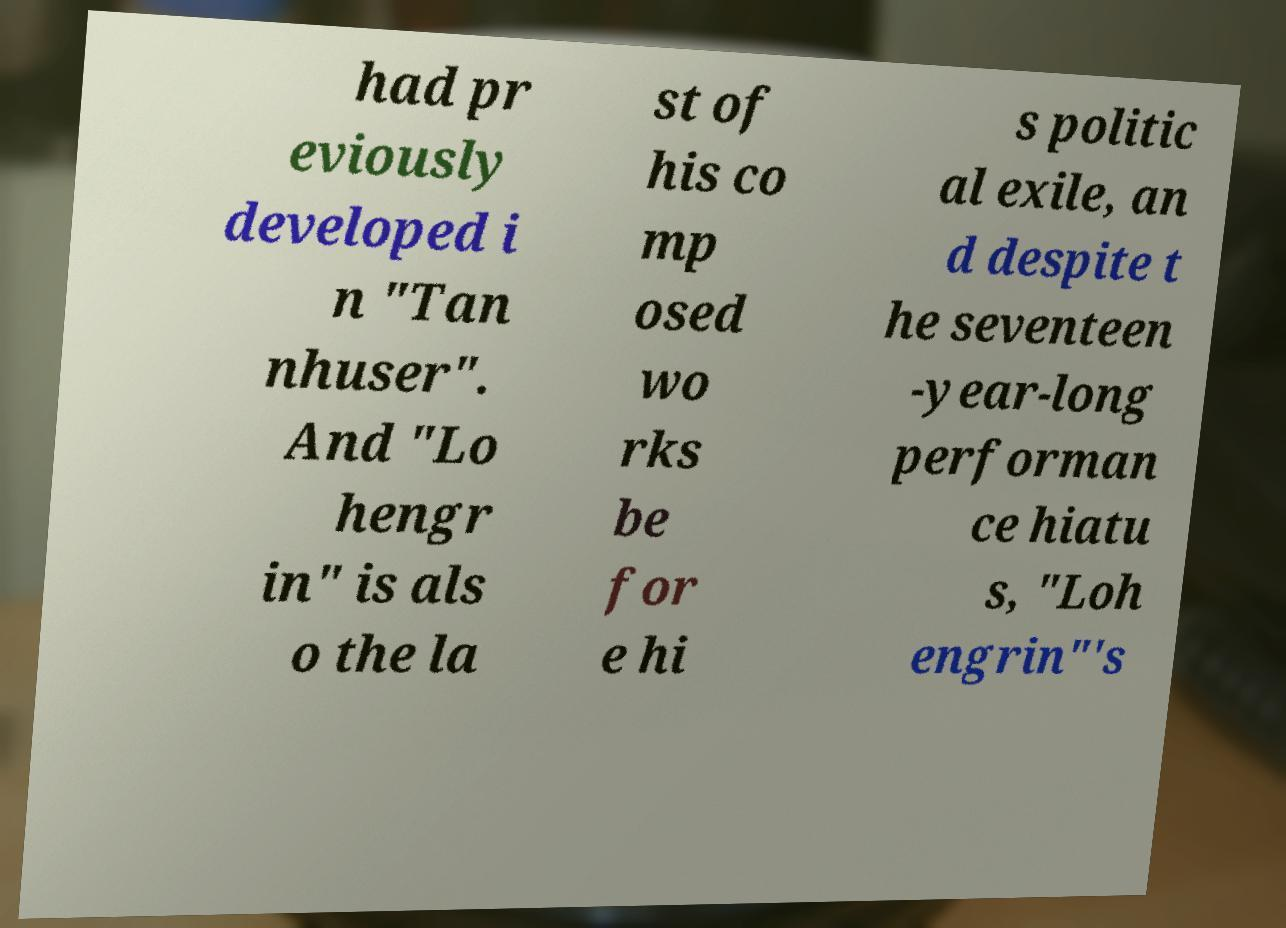What messages or text are displayed in this image? I need them in a readable, typed format. had pr eviously developed i n "Tan nhuser". And "Lo hengr in" is als o the la st of his co mp osed wo rks be for e hi s politic al exile, an d despite t he seventeen -year-long performan ce hiatu s, "Loh engrin"'s 